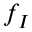<formula> <loc_0><loc_0><loc_500><loc_500>f _ { I }</formula> 